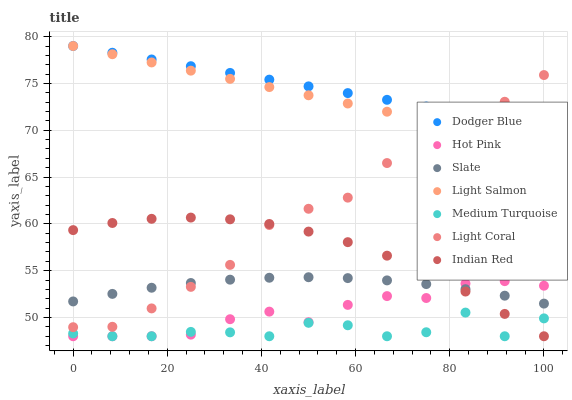Does Medium Turquoise have the minimum area under the curve?
Answer yes or no. Yes. Does Dodger Blue have the maximum area under the curve?
Answer yes or no. Yes. Does Indian Red have the minimum area under the curve?
Answer yes or no. No. Does Indian Red have the maximum area under the curve?
Answer yes or no. No. Is Dodger Blue the smoothest?
Answer yes or no. Yes. Is Medium Turquoise the roughest?
Answer yes or no. Yes. Is Indian Red the smoothest?
Answer yes or no. No. Is Indian Red the roughest?
Answer yes or no. No. Does Indian Red have the lowest value?
Answer yes or no. Yes. Does Slate have the lowest value?
Answer yes or no. No. Does Dodger Blue have the highest value?
Answer yes or no. Yes. Does Indian Red have the highest value?
Answer yes or no. No. Is Slate less than Dodger Blue?
Answer yes or no. Yes. Is Light Salmon greater than Indian Red?
Answer yes or no. Yes. Does Light Coral intersect Light Salmon?
Answer yes or no. Yes. Is Light Coral less than Light Salmon?
Answer yes or no. No. Is Light Coral greater than Light Salmon?
Answer yes or no. No. Does Slate intersect Dodger Blue?
Answer yes or no. No. 